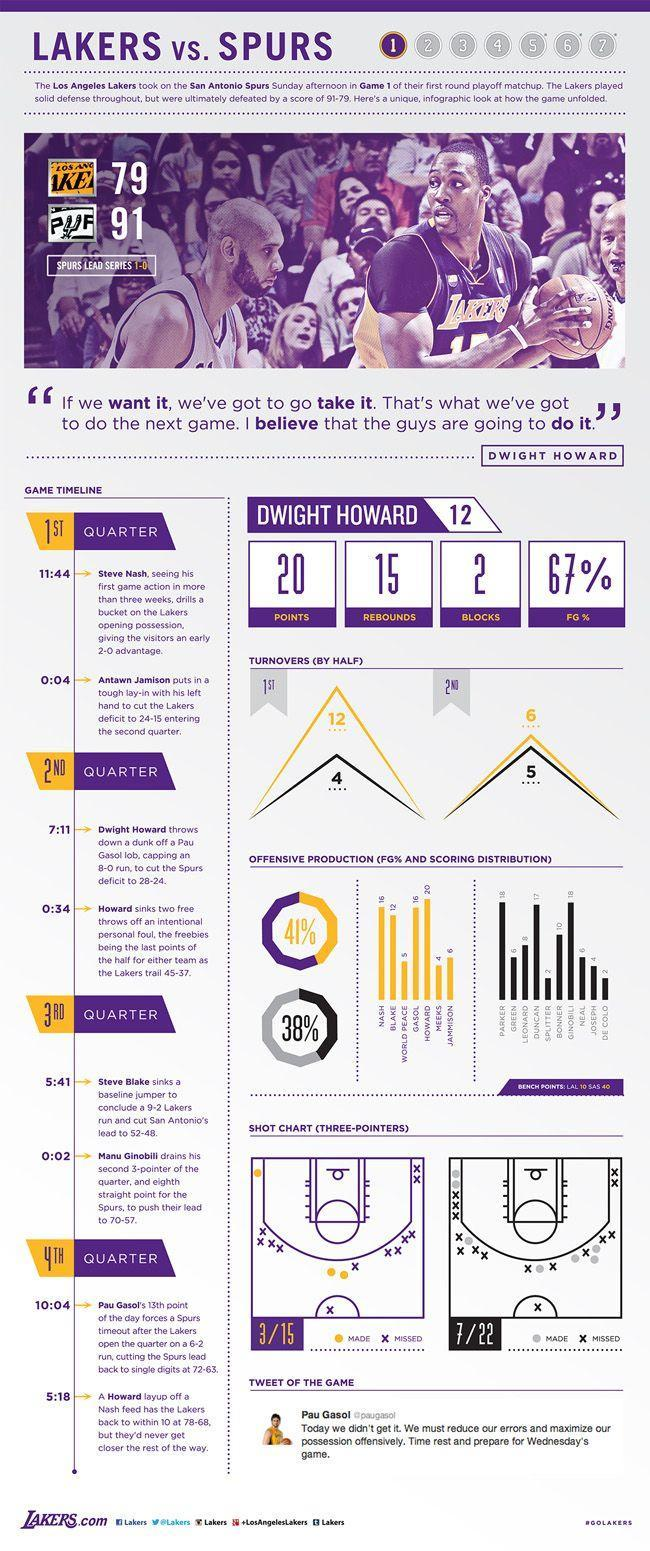As per shot chart, how many missed in 7/22
Answer the question with a short phrase. 15 how many rebounds for dwight howard 15 As per shot chart, how many missed in 3/15 12 